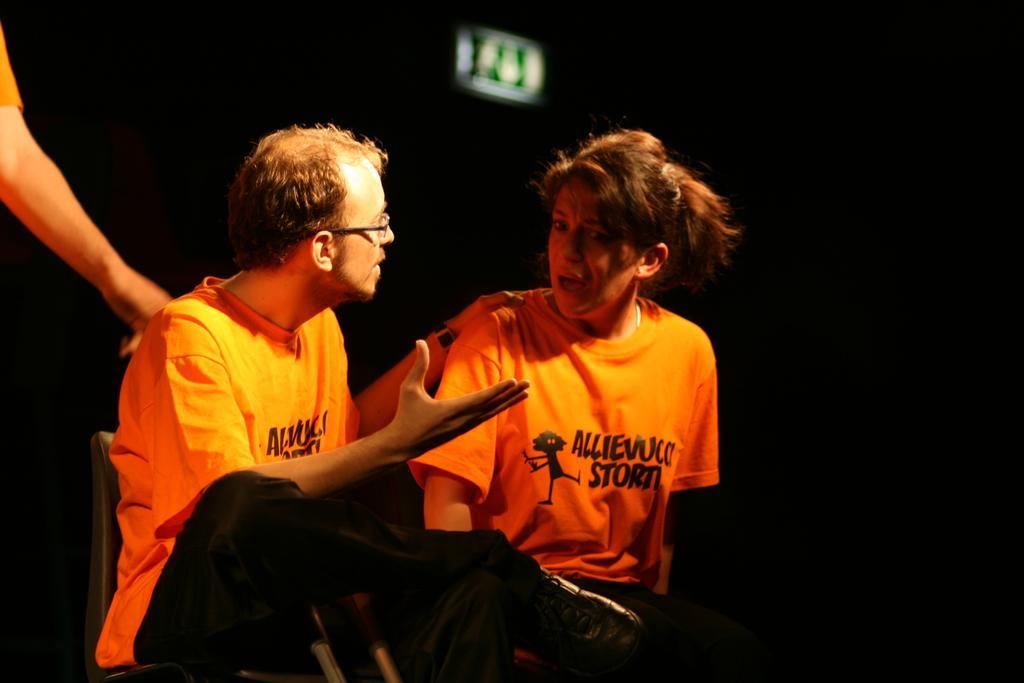Can you describe this image briefly? In this image, we can see persons on the dark background. These persons are wearing clothes and sitting on chairs. There is a person hand in the top left of the image. 